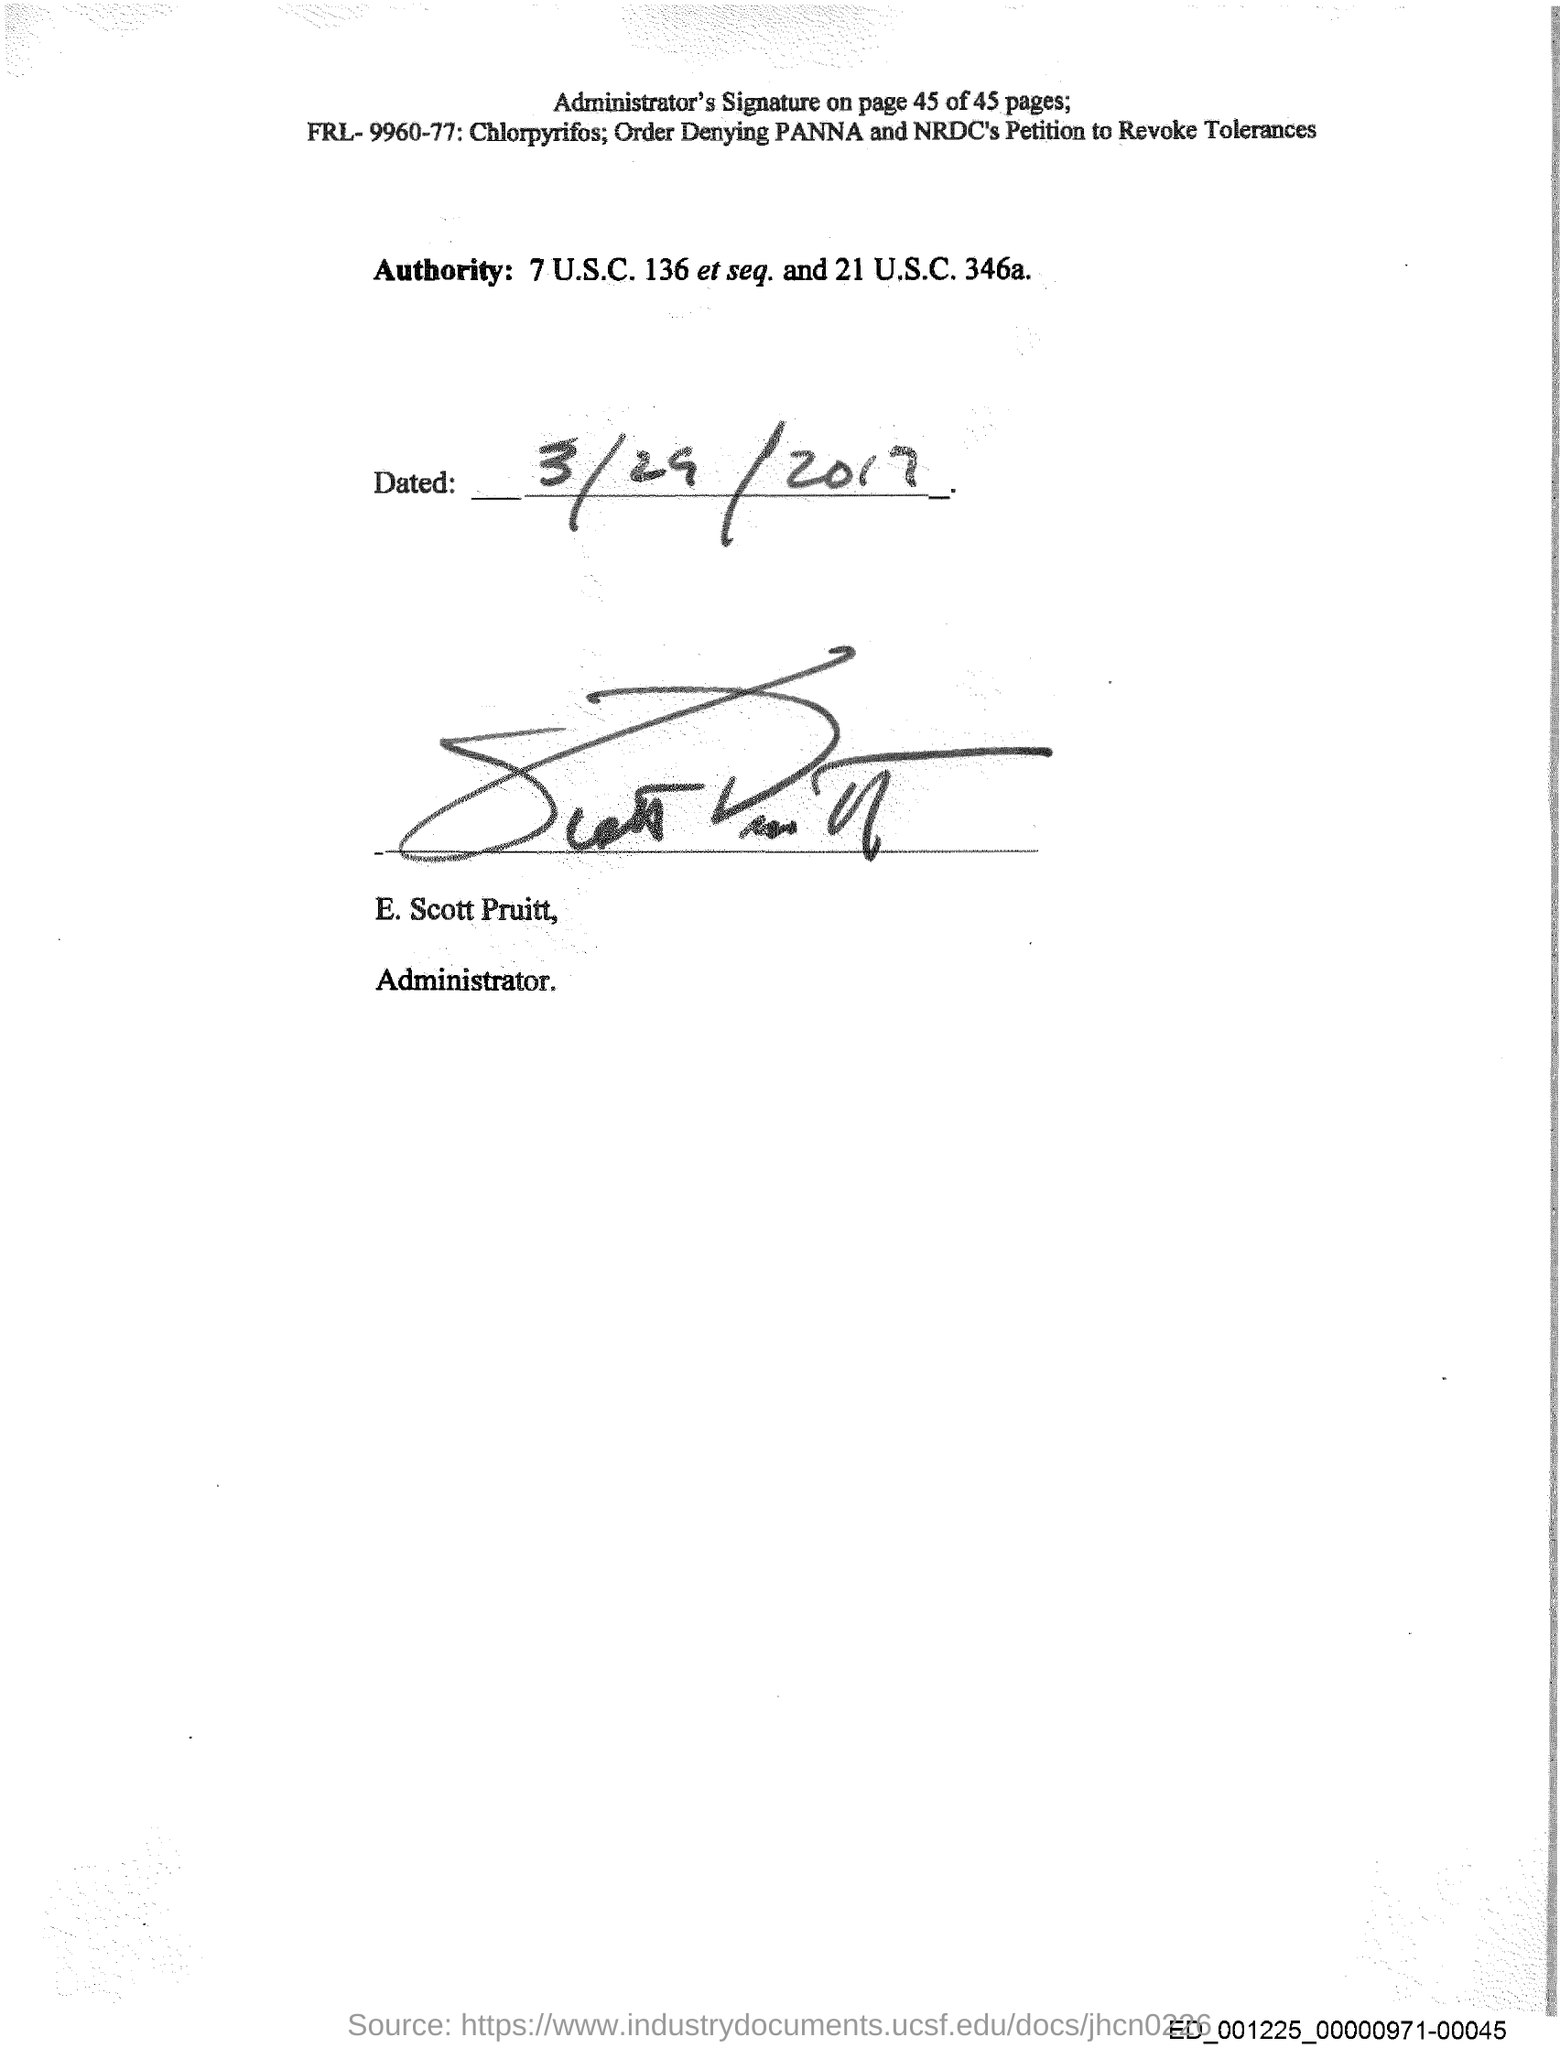What is the handwritten  date  above the signature?
Ensure brevity in your answer.  3/29/2017. Who has signed the document?
Offer a very short reply. E. Scott Pruitt. What is the designation of E. Scott Pruitt?
Give a very brief answer. Administrator. 